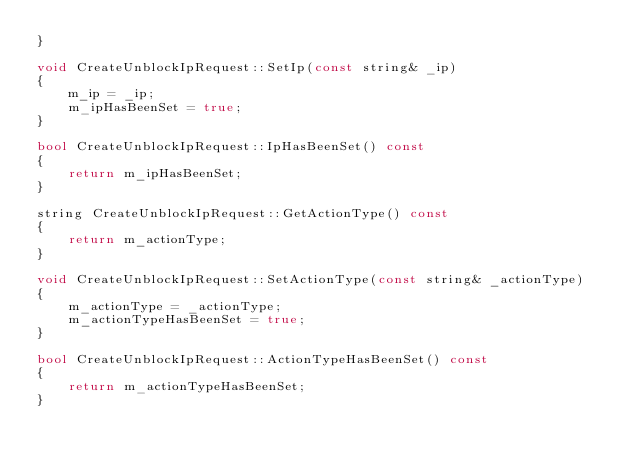<code> <loc_0><loc_0><loc_500><loc_500><_C++_>}

void CreateUnblockIpRequest::SetIp(const string& _ip)
{
    m_ip = _ip;
    m_ipHasBeenSet = true;
}

bool CreateUnblockIpRequest::IpHasBeenSet() const
{
    return m_ipHasBeenSet;
}

string CreateUnblockIpRequest::GetActionType() const
{
    return m_actionType;
}

void CreateUnblockIpRequest::SetActionType(const string& _actionType)
{
    m_actionType = _actionType;
    m_actionTypeHasBeenSet = true;
}

bool CreateUnblockIpRequest::ActionTypeHasBeenSet() const
{
    return m_actionTypeHasBeenSet;
}


</code> 